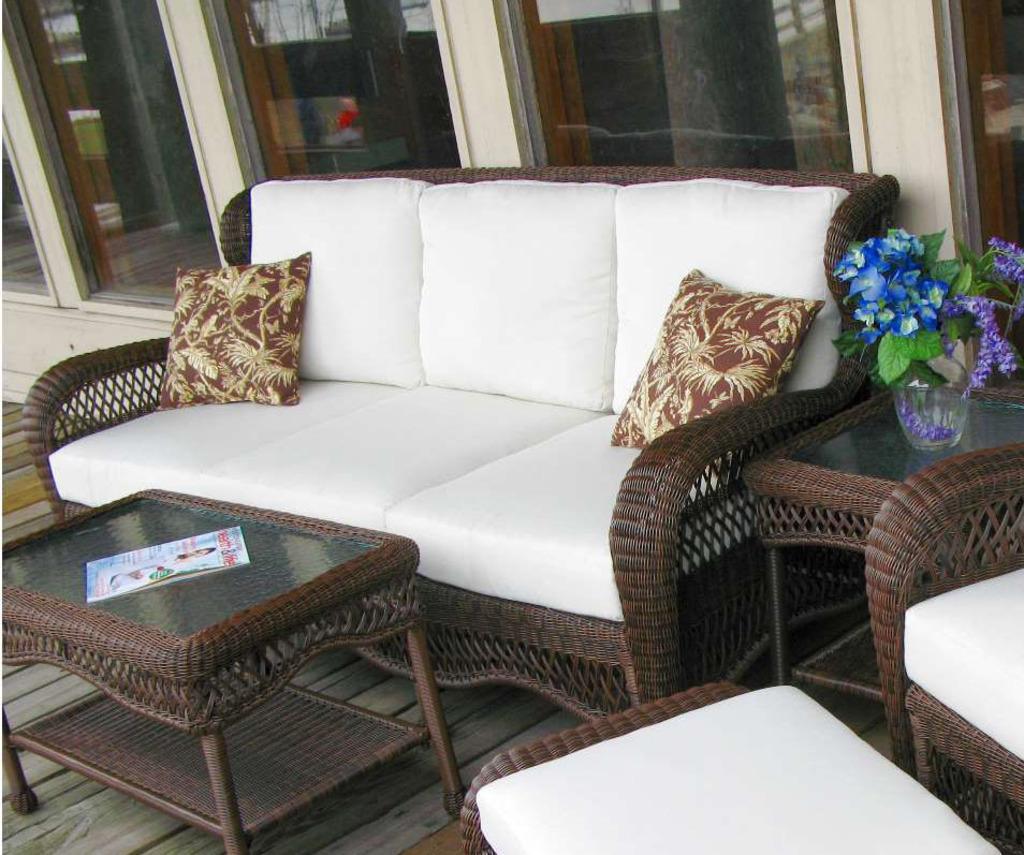Could you give a brief overview of what you see in this image? This image is clicked outside. There is a sofa in brown color. There are two pillows on the sofa. To the right, there is a table on which plant is kept. In the front, there is a teapoy. In the background there is a wall along with mirrors. 